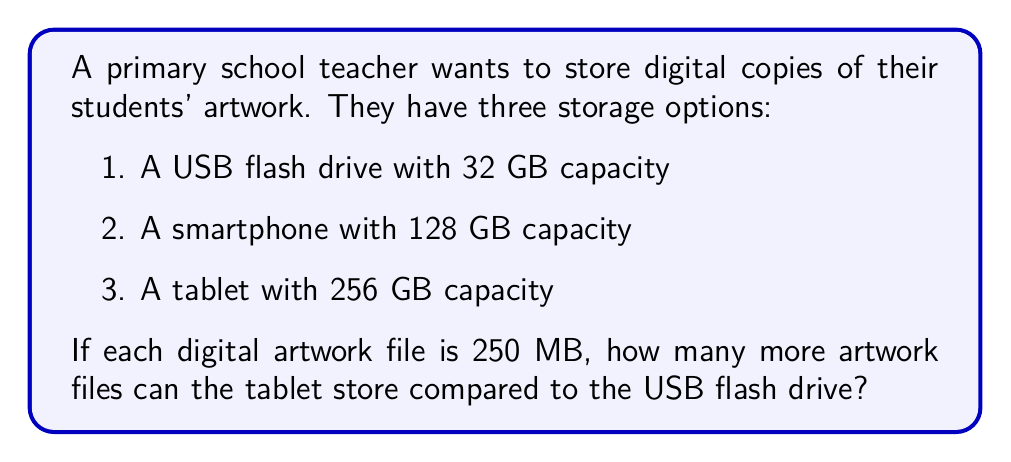Can you answer this question? Let's solve this step-by-step:

1. Convert all storage capacities to MB:
   - USB flash drive: $32 \text{ GB} = 32 \times 1024 \text{ MB} = 32768 \text{ MB}$
   - Smartphone: $128 \text{ GB} = 128 \times 1024 \text{ MB} = 131072 \text{ MB}$
   - Tablet: $256 \text{ GB} = 256 \times 1024 \text{ MB} = 262144 \text{ MB}$

2. Calculate the number of artwork files each device can store:
   - USB flash drive: $\frac{32768 \text{ MB}}{250 \text{ MB per file}} = 131.072 \approx 131 \text{ files}$
   - Smartphone: $\frac{131072 \text{ MB}}{250 \text{ MB per file}} = 524.288 \approx 524 \text{ files}$
   - Tablet: $\frac{262144 \text{ MB}}{250 \text{ MB per file}} = 1048.576 \approx 1048 \text{ files}$

3. Calculate the difference between the tablet and USB flash drive:
   $1048 - 131 = 917 \text{ files}$

Therefore, the tablet can store 917 more artwork files than the USB flash drive.
Answer: 917 files 